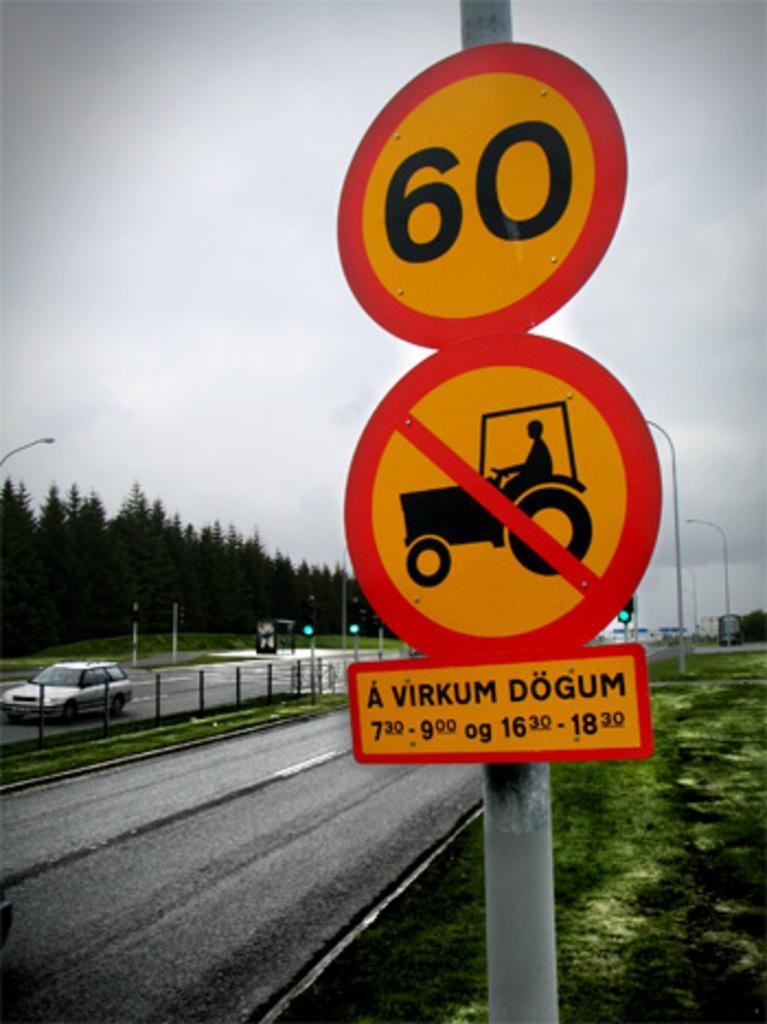In one or two sentences, can you explain what this image depicts? In this image in the foreground there is a pole and boards, at the bottom there is walkway, grass and some rods, vehicle and in the background there are poles, traffic signals, trees and buildings. At the top there is sky. 